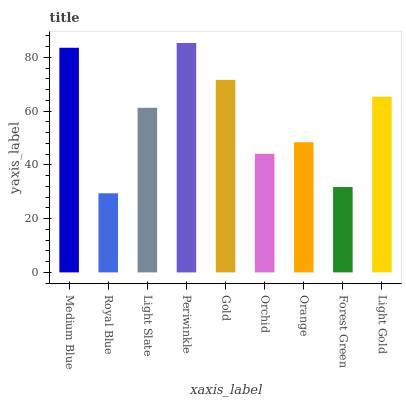Is Light Slate the minimum?
Answer yes or no. No. Is Light Slate the maximum?
Answer yes or no. No. Is Light Slate greater than Royal Blue?
Answer yes or no. Yes. Is Royal Blue less than Light Slate?
Answer yes or no. Yes. Is Royal Blue greater than Light Slate?
Answer yes or no. No. Is Light Slate less than Royal Blue?
Answer yes or no. No. Is Light Slate the high median?
Answer yes or no. Yes. Is Light Slate the low median?
Answer yes or no. Yes. Is Periwinkle the high median?
Answer yes or no. No. Is Orchid the low median?
Answer yes or no. No. 